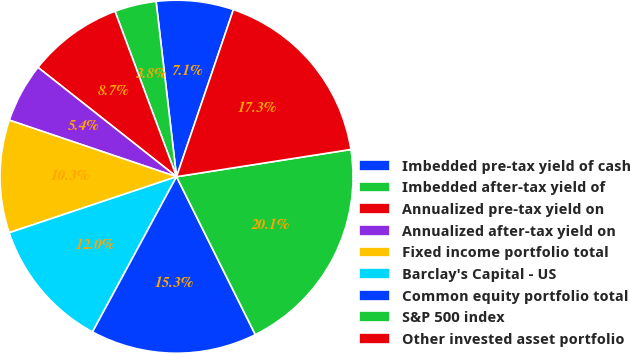<chart> <loc_0><loc_0><loc_500><loc_500><pie_chart><fcel>Imbedded pre-tax yield of cash<fcel>Imbedded after-tax yield of<fcel>Annualized pre-tax yield on<fcel>Annualized after-tax yield on<fcel>Fixed income portfolio total<fcel>Barclay's Capital - US<fcel>Common equity portfolio total<fcel>S&P 500 index<fcel>Other invested asset portfolio<nl><fcel>7.07%<fcel>3.82%<fcel>8.7%<fcel>5.44%<fcel>10.33%<fcel>11.96%<fcel>15.26%<fcel>20.1%<fcel>17.31%<nl></chart> 